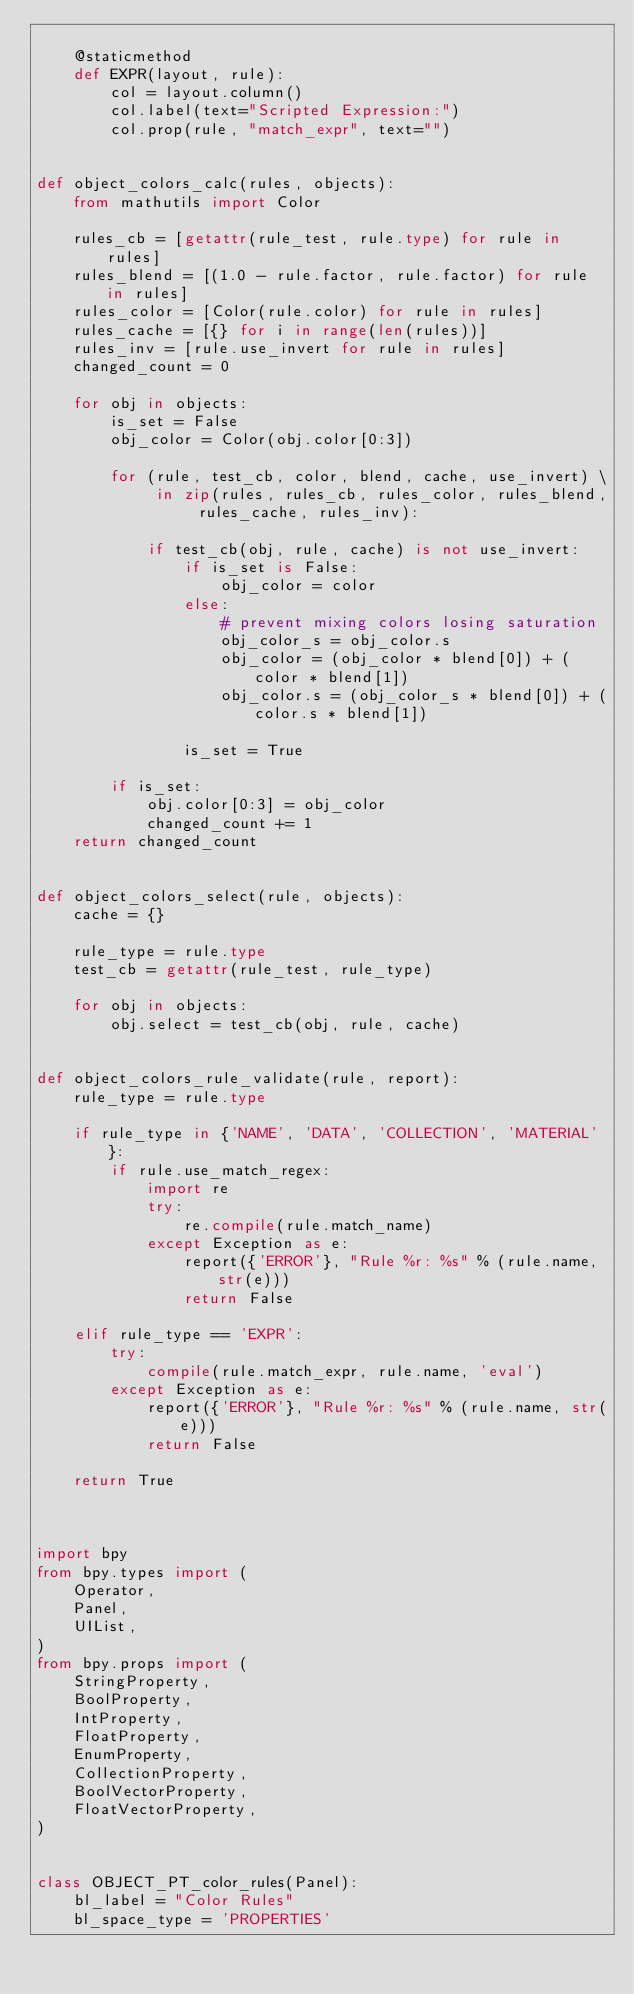Convert code to text. <code><loc_0><loc_0><loc_500><loc_500><_Python_>
    @staticmethod
    def EXPR(layout, rule):
        col = layout.column()
        col.label(text="Scripted Expression:")
        col.prop(rule, "match_expr", text="")


def object_colors_calc(rules, objects):
    from mathutils import Color

    rules_cb = [getattr(rule_test, rule.type) for rule in rules]
    rules_blend = [(1.0 - rule.factor, rule.factor) for rule in rules]
    rules_color = [Color(rule.color) for rule in rules]
    rules_cache = [{} for i in range(len(rules))]
    rules_inv = [rule.use_invert for rule in rules]
    changed_count = 0

    for obj in objects:
        is_set = False
        obj_color = Color(obj.color[0:3])

        for (rule, test_cb, color, blend, cache, use_invert) \
             in zip(rules, rules_cb, rules_color, rules_blend, rules_cache, rules_inv):

            if test_cb(obj, rule, cache) is not use_invert:
                if is_set is False:
                    obj_color = color
                else:
                    # prevent mixing colors losing saturation
                    obj_color_s = obj_color.s
                    obj_color = (obj_color * blend[0]) + (color * blend[1])
                    obj_color.s = (obj_color_s * blend[0]) + (color.s * blend[1])

                is_set = True

        if is_set:
            obj.color[0:3] = obj_color
            changed_count += 1
    return changed_count


def object_colors_select(rule, objects):
    cache = {}

    rule_type = rule.type
    test_cb = getattr(rule_test, rule_type)

    for obj in objects:
        obj.select = test_cb(obj, rule, cache)


def object_colors_rule_validate(rule, report):
    rule_type = rule.type

    if rule_type in {'NAME', 'DATA', 'COLLECTION', 'MATERIAL'}:
        if rule.use_match_regex:
            import re
            try:
                re.compile(rule.match_name)
            except Exception as e:
                report({'ERROR'}, "Rule %r: %s" % (rule.name, str(e)))
                return False

    elif rule_type == 'EXPR':
        try:
            compile(rule.match_expr, rule.name, 'eval')
        except Exception as e:
            report({'ERROR'}, "Rule %r: %s" % (rule.name, str(e)))
            return False

    return True



import bpy
from bpy.types import (
    Operator,
    Panel,
    UIList,
)
from bpy.props import (
    StringProperty,
    BoolProperty,
    IntProperty,
    FloatProperty,
    EnumProperty,
    CollectionProperty,
    BoolVectorProperty,
    FloatVectorProperty,
)


class OBJECT_PT_color_rules(Panel):
    bl_label = "Color Rules"
    bl_space_type = 'PROPERTIES'</code> 